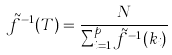Convert formula to latex. <formula><loc_0><loc_0><loc_500><loc_500>\tilde { f } ^ { - 1 } ( T ) = \frac { N } { \sum _ { i = 1 } ^ { p } \tilde { f } ^ { - 1 } ( k _ { i } ) }</formula> 